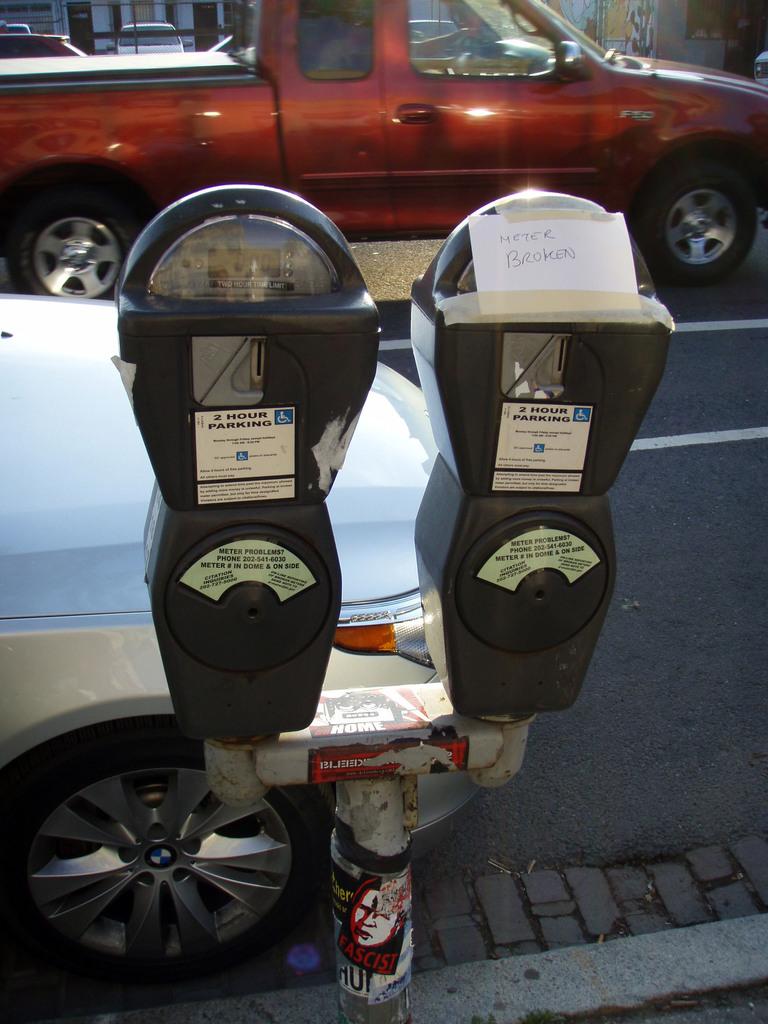What does the paper warn us of?
Give a very brief answer. Meter broken. 